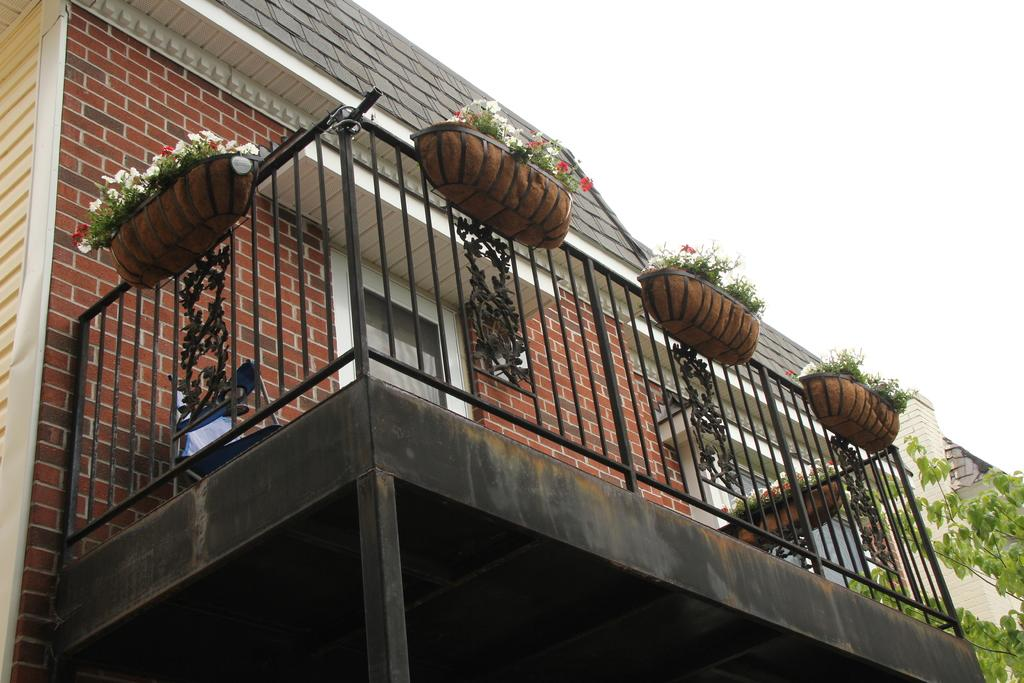What type of structure is present in the image? There is a building in the image. What is located near the building? There is a fence in the image. What type of vegetation can be seen in the image? There are house plants and a tree in the image. What can be seen in the background of the image? The sky is visible in the image. Can you determine the time of day the image was taken? The image was likely taken during the day, as the sky is visible. What type of mitten is being used to touch the texture of the tree in the image? There is no mitten present in the image, and the tree's texture cannot be determined from the image. What type of bird can be seen perched on the fence in the image? There is no bird present on the fence in the image. 